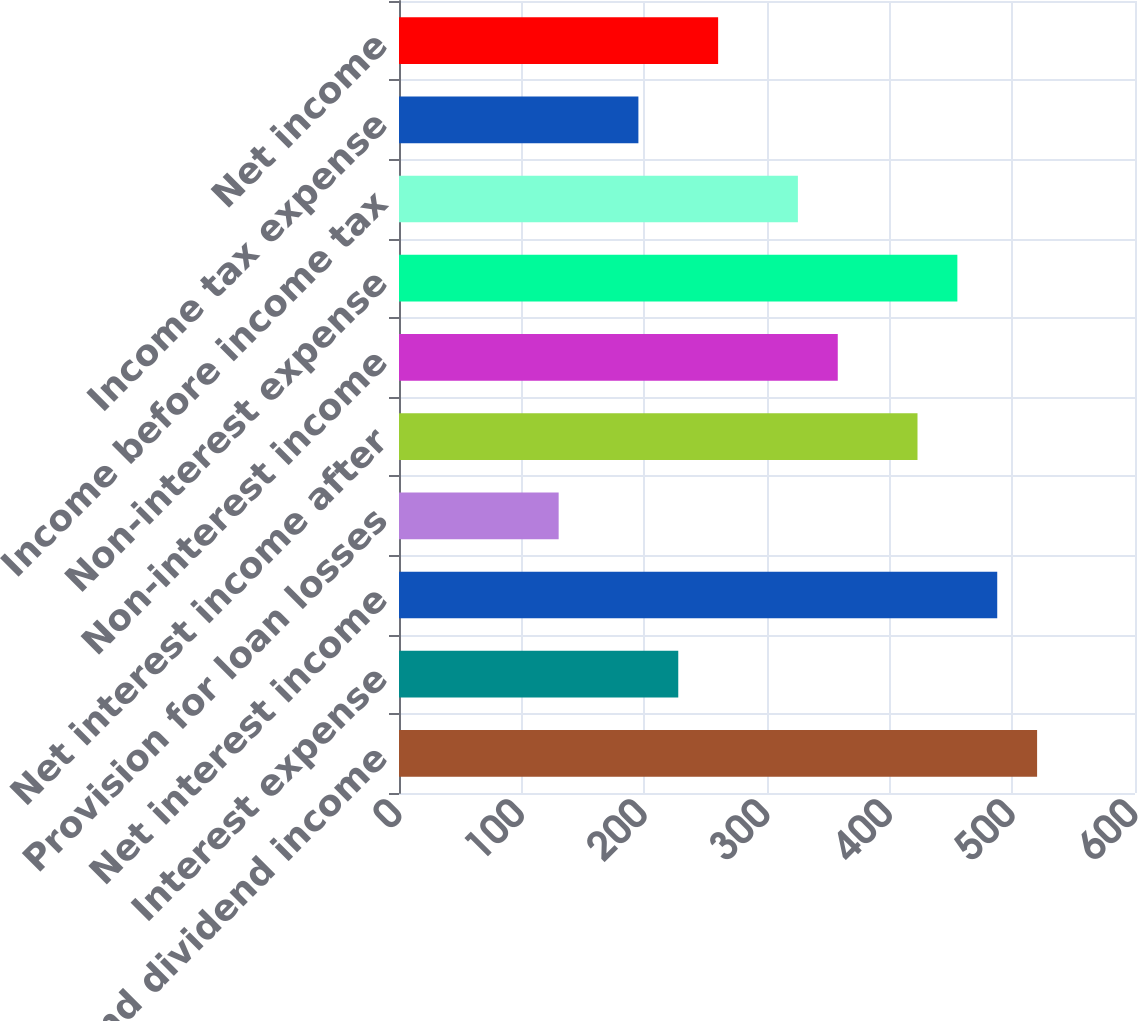<chart> <loc_0><loc_0><loc_500><loc_500><bar_chart><fcel>Interest and dividend income<fcel>Interest expense<fcel>Net interest income<fcel>Provision for loan losses<fcel>Net interest income after<fcel>Non-interest income<fcel>Non-interest expense<fcel>Income before income tax<fcel>Income tax expense<fcel>Net income<nl><fcel>520.19<fcel>227.66<fcel>487.69<fcel>130.16<fcel>422.69<fcel>357.69<fcel>455.19<fcel>325.18<fcel>195.16<fcel>260.16<nl></chart> 